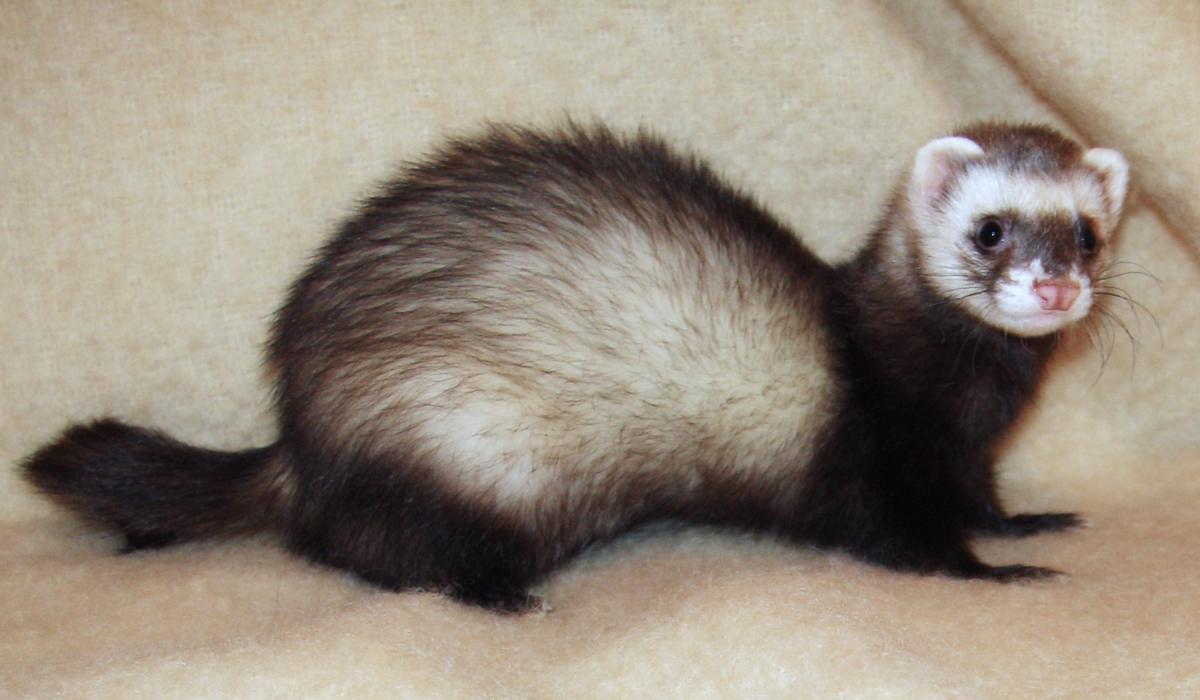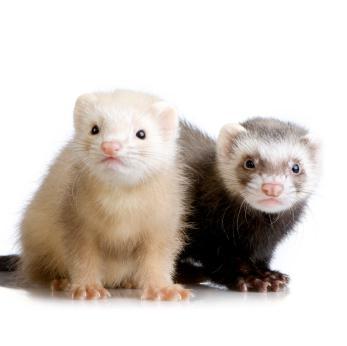The first image is the image on the left, the second image is the image on the right. Analyze the images presented: Is the assertion "At least one image contains a cream colored and a masked ferret." valid? Answer yes or no. Yes. 